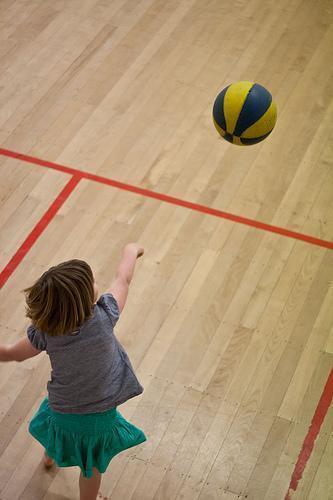How many children are there?
Give a very brief answer. 1. 